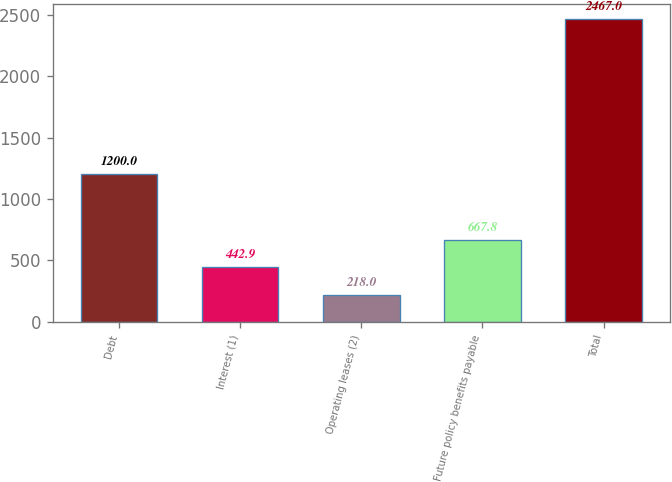Convert chart to OTSL. <chart><loc_0><loc_0><loc_500><loc_500><bar_chart><fcel>Debt<fcel>Interest (1)<fcel>Operating leases (2)<fcel>Future policy benefits payable<fcel>Total<nl><fcel>1200<fcel>442.9<fcel>218<fcel>667.8<fcel>2467<nl></chart> 